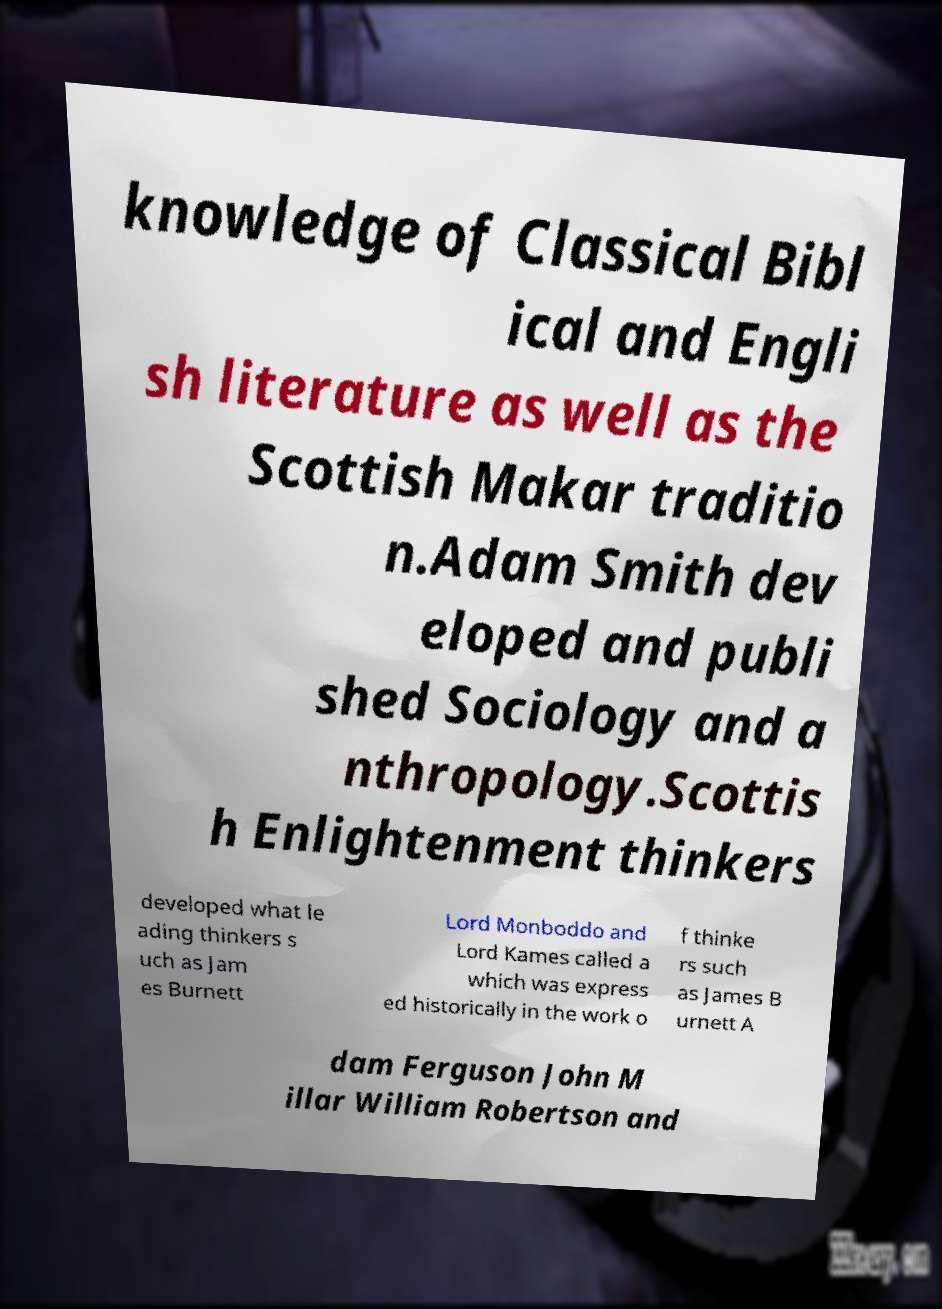Please identify and transcribe the text found in this image. knowledge of Classical Bibl ical and Engli sh literature as well as the Scottish Makar traditio n.Adam Smith dev eloped and publi shed Sociology and a nthropology.Scottis h Enlightenment thinkers developed what le ading thinkers s uch as Jam es Burnett Lord Monboddo and Lord Kames called a which was express ed historically in the work o f thinke rs such as James B urnett A dam Ferguson John M illar William Robertson and 